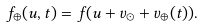<formula> <loc_0><loc_0><loc_500><loc_500>f _ { \oplus } ( { u } , t ) = f ( { u } + { v } _ { \odot } + { v } _ { \oplus } ( t ) ) .</formula> 